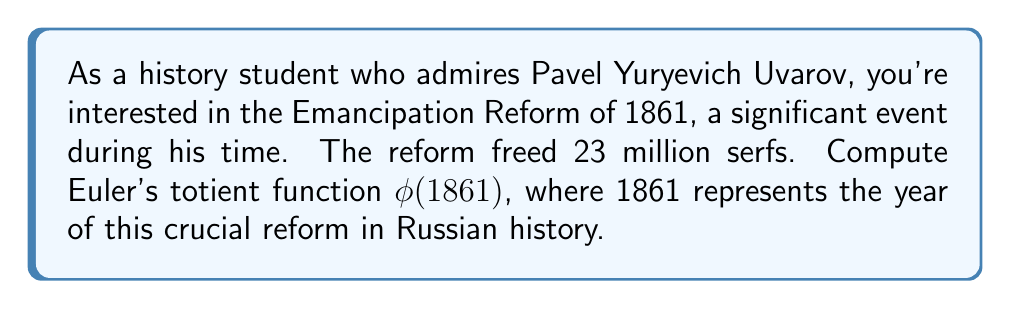Teach me how to tackle this problem. To compute Euler's totient function $\phi(1861)$, we need to follow these steps:

1) First, let's factor 1861 into its prime factors:
   $1861 = 11 \times 13 \times 13$

2) Now, we can use the multiplicative property of Euler's totient function for prime powers:
   For a prime $p$ and a positive integer $k$, $\phi(p^k) = p^k - p^{k-1}$

3) In our case, we have:
   $\phi(1861) = \phi(11) \times \phi(13^2)$

4) Let's calculate each part:
   $\phi(11) = 11 - 1 = 10$ (since 11 is prime)
   $\phi(13^2) = 13^2 - 13 = 169 - 13 = 156$

5) Now, we multiply these results:
   $\phi(1861) = 10 \times 156 = 1560$

Therefore, the value of Euler's totient function for 1861 is 1560.

This means that there are 1560 numbers less than or equal to 1861 that are coprime to 1861.
Answer: $\phi(1861) = 1560$ 